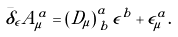<formula> <loc_0><loc_0><loc_500><loc_500>\bar { \delta } _ { \epsilon } A _ { \mu } ^ { a } = \left ( D _ { \mu } \right ) _ { \, b } ^ { a } \epsilon ^ { b } + \epsilon _ { \mu } ^ { a } .</formula> 